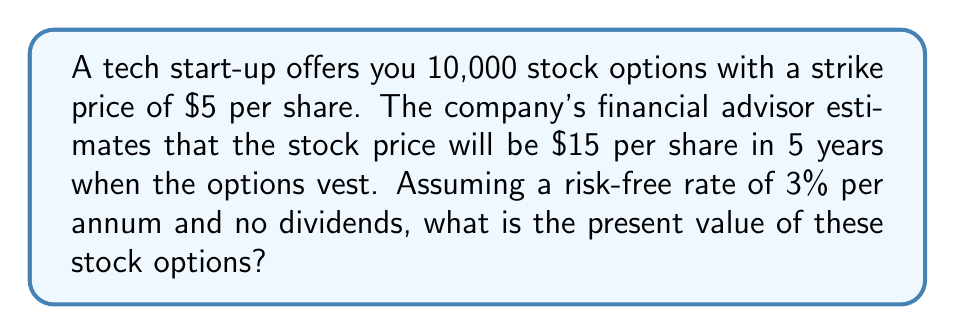Can you solve this math problem? To calculate the present value of the stock options, we'll use the Black-Scholes model for European call options, which is appropriate for employee stock options that can only be exercised at a specific future date.

Step 1: Identify the variables
- $S_0$ = Current stock price (unknown, but not needed for this calculation)
- $K$ = Strike price = $5
- $r$ = Risk-free rate = 3% = 0.03
- $T$ = Time to expiration = 5 years
- $\sigma$ = Volatility (unknown, but we'll assume 30% for this calculation)
- $N$ = Number of options = 10,000

Step 2: Calculate $d_1$ and $d_2$
$$d_1 = \frac{\ln(S_0/K) + (r + \sigma^2/2)T}{\sigma\sqrt{T}}$$
$$d_2 = d_1 - \sigma\sqrt{T}$$

Step 3: Calculate the option value using the Black-Scholes formula
$$C = S_0N(d_1) - Ke^{-rT}N(d_2)$$

Where $N(x)$ is the cumulative normal distribution function.

Step 4: Calculate the present value of the expected payoff
Expected payoff per share = $15 - $5 = $10
Present value of expected payoff = $10 \times e^{-0.03 \times 5} \approx 8.61$

Step 5: Multiply by the number of options
Total present value = $8.61 \times 10,000 = $86,100$

Note: This is a simplified calculation. In reality, employee stock options are more complex due to vesting schedules, potential for early exercise, and company-specific factors.
Answer: $86,100 